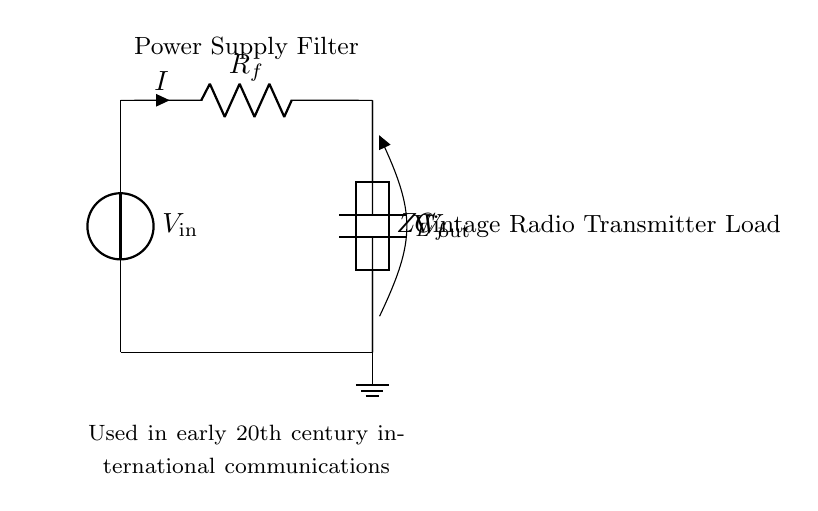What is the type of load connected in this circuit? The load depicted in the circuit is a generic load represented by the symbol Z_L, indicating it can be resistive, inductive, or capacitive.
Answer: Generic load What does the resistor labeled R_f do in this circuit? The resistor R_f limits the current I flowing through the circuit, which is crucial for protecting circuit components while influencing the voltage drop across it.
Answer: Limits current What is the purpose of the capacitor C_f in this circuit? The capacitor C_f acts as a filter component, smoothing the output voltage by storing and releasing charge, thereby reducing voltage ripples.
Answer: Filter voltage What is the voltage source labeled V_in in reference to? The V_in voltage source provides the necessary supply voltage for the circuit, enabling it to function and power the associated load.
Answer: Supply voltage How does the configuration of R_f and C_f affect the output voltage? The combination of R_f and C_f in this RC filter configuration determines the time constant, which influences the charging and discharging rates of the capacitor, ultimately affecting the output voltage behavior during operation.
Answer: Affects voltage behavior What can be inferred about the frequency response of the circuit with respect to R_f and C_f? The resistor and capacitor together create an RC low-pass filter, meaning this configuration allows low-frequency signals to pass while attenuating higher frequencies, which is critical for the clarity of the radio transmitter signal.
Answer: Low-pass filter 